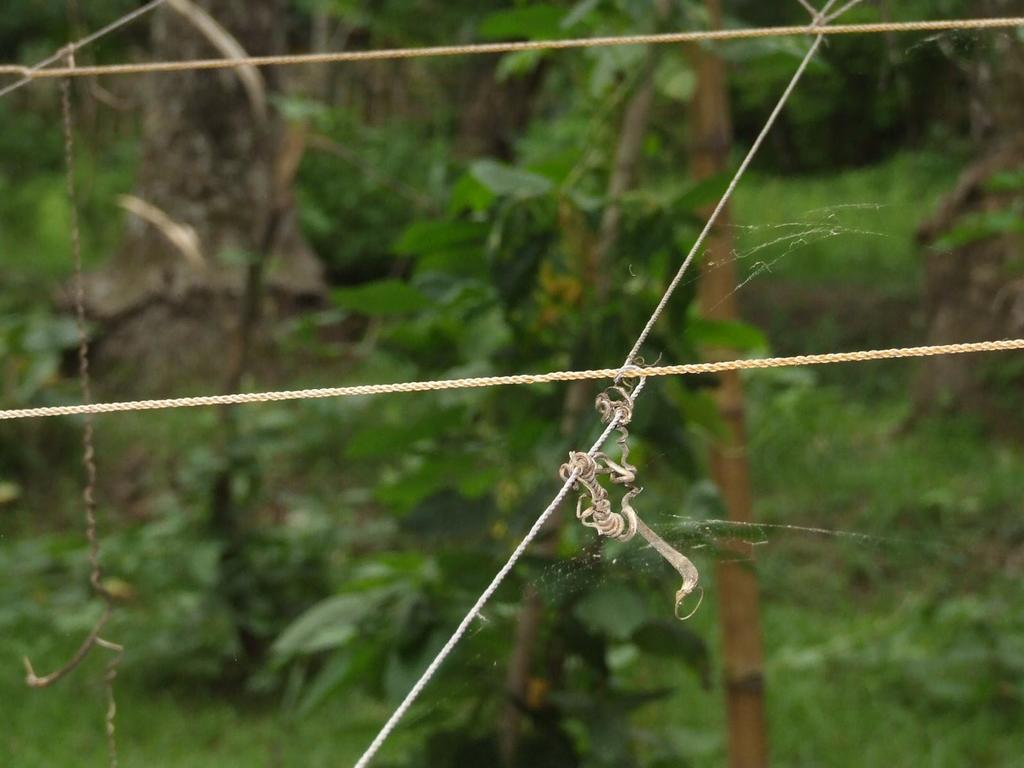What type of objects can be seen in the image? There are ropes, creepers, and spider webs in the image. What can be found in the background of the image? There are trees in the background of the image. What type of trucks can be seen driving through the spider webs in the image? There are no trucks present in the image, and the spider webs are not depicted as being traversed by any vehicles. 